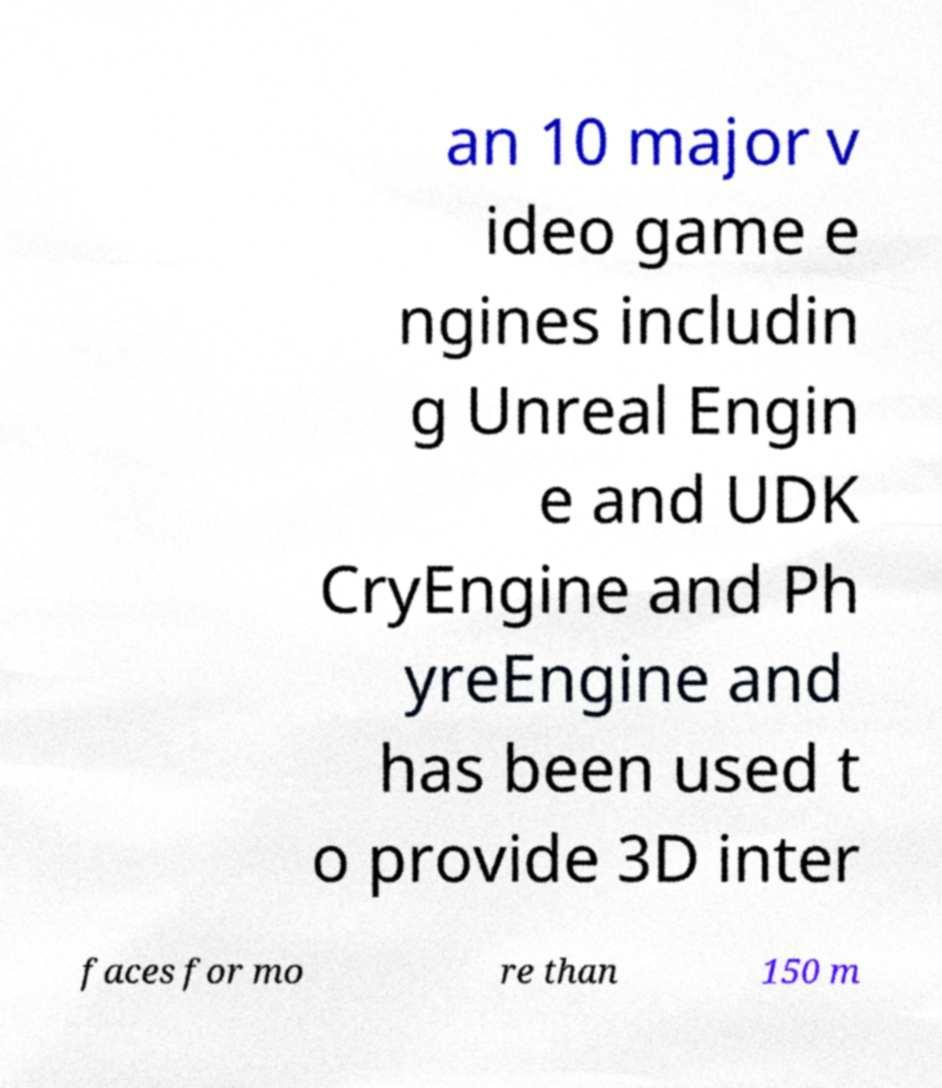For documentation purposes, I need the text within this image transcribed. Could you provide that? an 10 major v ideo game e ngines includin g Unreal Engin e and UDK CryEngine and Ph yreEngine and has been used t o provide 3D inter faces for mo re than 150 m 